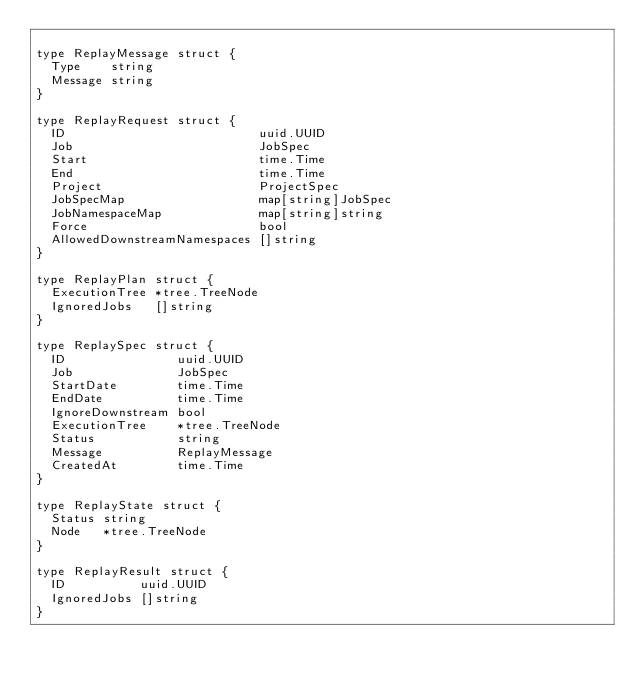Convert code to text. <code><loc_0><loc_0><loc_500><loc_500><_Go_>
type ReplayMessage struct {
	Type    string
	Message string
}

type ReplayRequest struct {
	ID                          uuid.UUID
	Job                         JobSpec
	Start                       time.Time
	End                         time.Time
	Project                     ProjectSpec
	JobSpecMap                  map[string]JobSpec
	JobNamespaceMap             map[string]string
	Force                       bool
	AllowedDownstreamNamespaces []string
}

type ReplayPlan struct {
	ExecutionTree *tree.TreeNode
	IgnoredJobs   []string
}

type ReplaySpec struct {
	ID               uuid.UUID
	Job              JobSpec
	StartDate        time.Time
	EndDate          time.Time
	IgnoreDownstream bool
	ExecutionTree    *tree.TreeNode
	Status           string
	Message          ReplayMessage
	CreatedAt        time.Time
}

type ReplayState struct {
	Status string
	Node   *tree.TreeNode
}

type ReplayResult struct {
	ID          uuid.UUID
	IgnoredJobs []string
}
</code> 